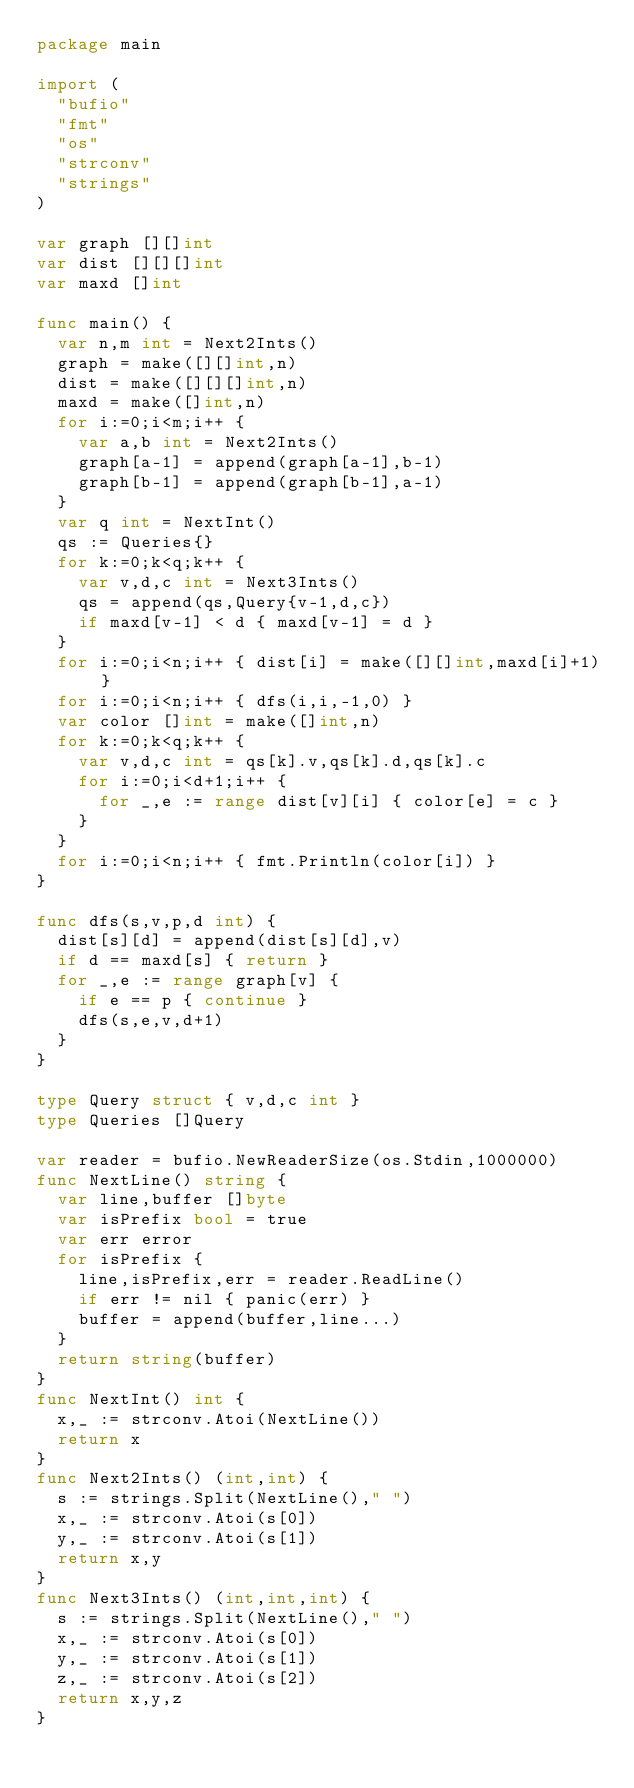Convert code to text. <code><loc_0><loc_0><loc_500><loc_500><_Go_>package main

import (
  "bufio"
  "fmt"
  "os"
  "strconv"
  "strings"
)

var graph [][]int
var dist [][][]int
var maxd []int

func main() {
  var n,m int = Next2Ints()
  graph = make([][]int,n)
  dist = make([][][]int,n)
  maxd = make([]int,n)
  for i:=0;i<m;i++ {
    var a,b int = Next2Ints()
    graph[a-1] = append(graph[a-1],b-1)
    graph[b-1] = append(graph[b-1],a-1)
  }
  var q int = NextInt()
  qs := Queries{}
  for k:=0;k<q;k++ {
    var v,d,c int = Next3Ints()
    qs = append(qs,Query{v-1,d,c})
    if maxd[v-1] < d { maxd[v-1] = d }
  }
  for i:=0;i<n;i++ { dist[i] = make([][]int,maxd[i]+1) }
  for i:=0;i<n;i++ { dfs(i,i,-1,0) }
  var color []int = make([]int,n)
  for k:=0;k<q;k++ {
    var v,d,c int = qs[k].v,qs[k].d,qs[k].c
    for i:=0;i<d+1;i++ {
      for _,e := range dist[v][i] { color[e] = c }
    }
  }
  for i:=0;i<n;i++ { fmt.Println(color[i]) }
}

func dfs(s,v,p,d int) {
  dist[s][d] = append(dist[s][d],v)
  if d == maxd[s] { return }
  for _,e := range graph[v] {
    if e == p { continue }
    dfs(s,e,v,d+1)
  }
}

type Query struct { v,d,c int }
type Queries []Query

var reader = bufio.NewReaderSize(os.Stdin,1000000)
func NextLine() string {
  var line,buffer []byte
  var isPrefix bool = true
  var err error
  for isPrefix {
    line,isPrefix,err = reader.ReadLine()
    if err != nil { panic(err) }
    buffer = append(buffer,line...)
  }
  return string(buffer)
}
func NextInt() int {
  x,_ := strconv.Atoi(NextLine())
  return x
}
func Next2Ints() (int,int) {
  s := strings.Split(NextLine()," ")
  x,_ := strconv.Atoi(s[0])
  y,_ := strconv.Atoi(s[1])
  return x,y
}
func Next3Ints() (int,int,int) {
  s := strings.Split(NextLine()," ")
  x,_ := strconv.Atoi(s[0])
  y,_ := strconv.Atoi(s[1])
  z,_ := strconv.Atoi(s[2])
  return x,y,z
}</code> 